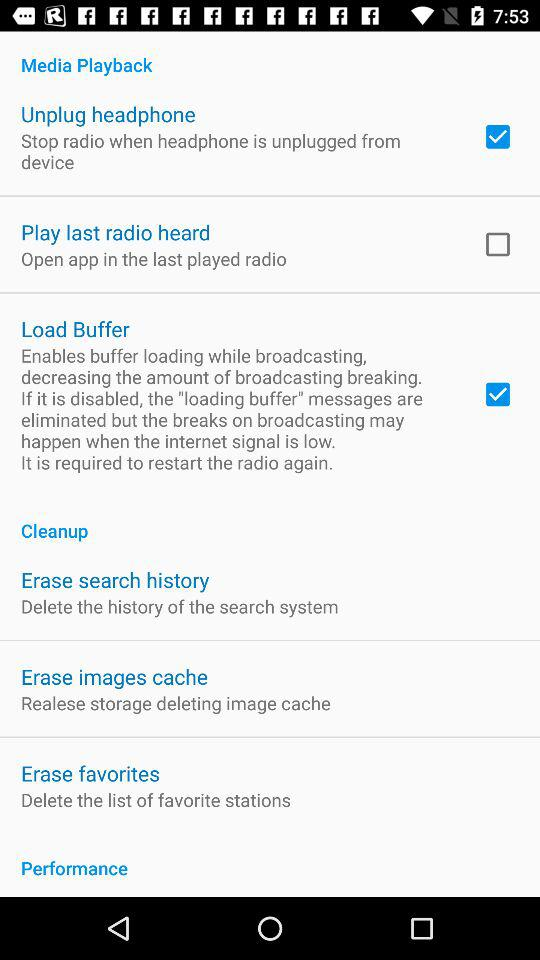What are the options available in "Cleanup"? The available options are "Erase search history", "Erase images cache" and "Erase favorites". 